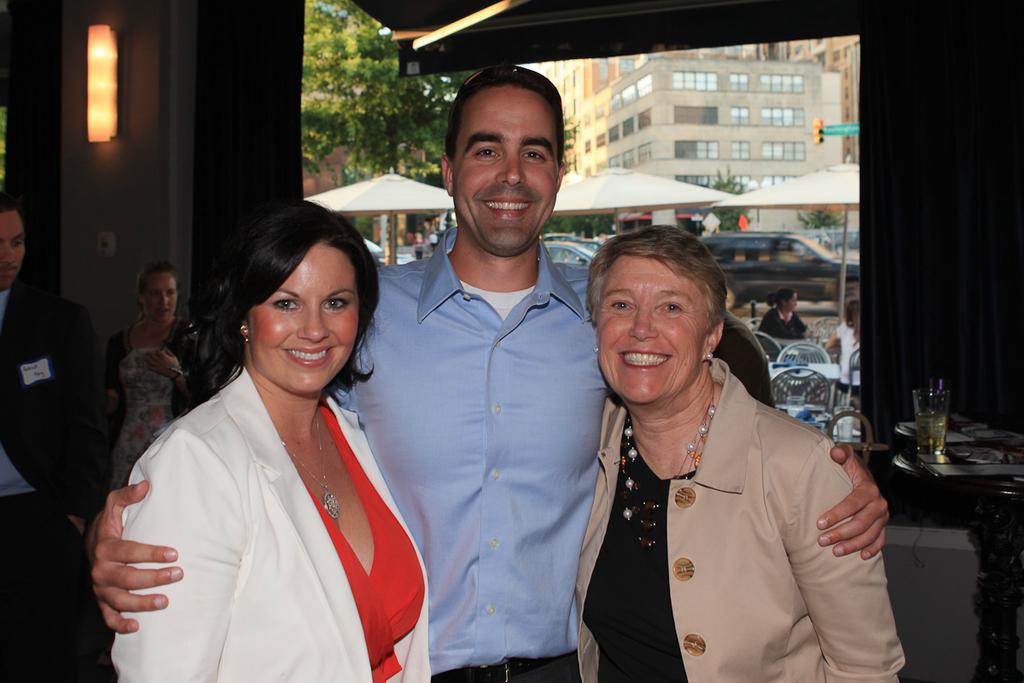How would you summarize this image in a sentence or two? In this picture I can see few people are standing and I can see smile on their faces and I can see a glass on the table and I can see few umbrellas and chairs and tables in the back and I can see a woman seated in the chair and few cars parked and I can see buildings and trees in the back and I can see light on the wall. 